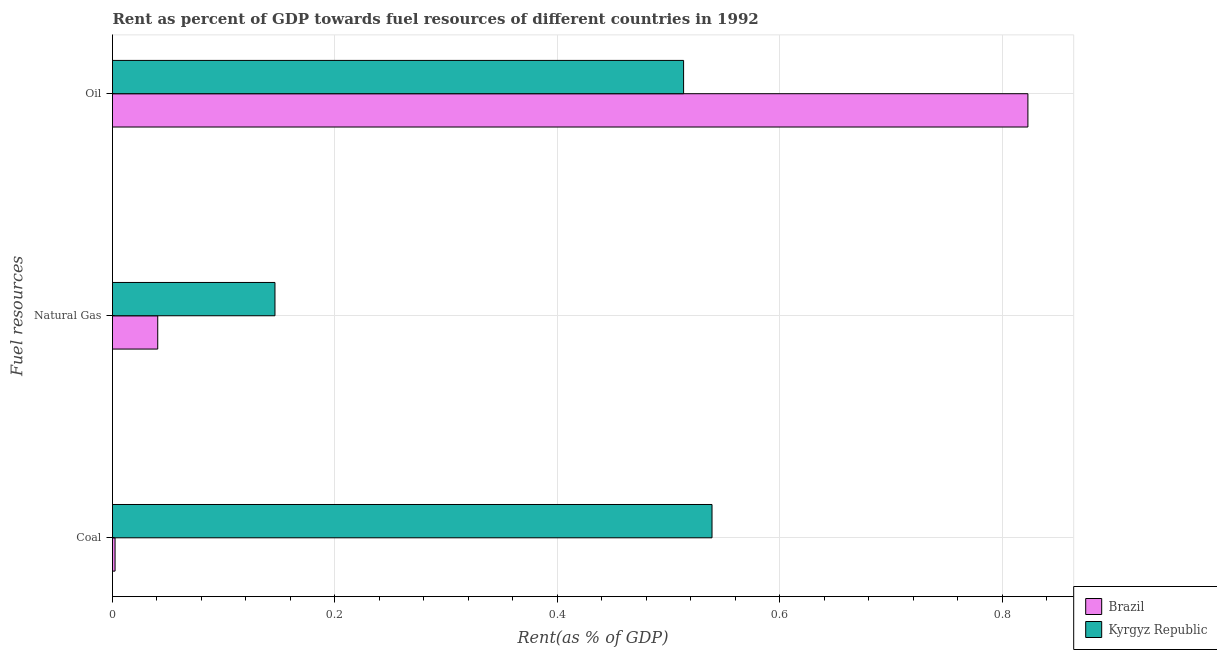How many different coloured bars are there?
Your response must be concise. 2. Are the number of bars per tick equal to the number of legend labels?
Your response must be concise. Yes. What is the label of the 3rd group of bars from the top?
Provide a short and direct response. Coal. What is the rent towards oil in Kyrgyz Republic?
Keep it short and to the point. 0.51. Across all countries, what is the maximum rent towards natural gas?
Offer a very short reply. 0.15. Across all countries, what is the minimum rent towards coal?
Provide a succinct answer. 0. In which country was the rent towards natural gas maximum?
Keep it short and to the point. Kyrgyz Republic. What is the total rent towards coal in the graph?
Give a very brief answer. 0.54. What is the difference between the rent towards natural gas in Brazil and that in Kyrgyz Republic?
Your response must be concise. -0.11. What is the difference between the rent towards natural gas in Brazil and the rent towards coal in Kyrgyz Republic?
Ensure brevity in your answer.  -0.5. What is the average rent towards oil per country?
Offer a terse response. 0.67. What is the difference between the rent towards coal and rent towards natural gas in Kyrgyz Republic?
Keep it short and to the point. 0.39. In how many countries, is the rent towards oil greater than 0.52 %?
Give a very brief answer. 1. What is the ratio of the rent towards oil in Brazil to that in Kyrgyz Republic?
Your response must be concise. 1.6. Is the rent towards oil in Kyrgyz Republic less than that in Brazil?
Provide a succinct answer. Yes. Is the difference between the rent towards natural gas in Kyrgyz Republic and Brazil greater than the difference between the rent towards coal in Kyrgyz Republic and Brazil?
Ensure brevity in your answer.  No. What is the difference between the highest and the second highest rent towards natural gas?
Your answer should be compact. 0.11. What is the difference between the highest and the lowest rent towards natural gas?
Offer a very short reply. 0.11. In how many countries, is the rent towards coal greater than the average rent towards coal taken over all countries?
Keep it short and to the point. 1. What does the 2nd bar from the top in Natural Gas represents?
Make the answer very short. Brazil. Is it the case that in every country, the sum of the rent towards coal and rent towards natural gas is greater than the rent towards oil?
Give a very brief answer. No. How many bars are there?
Provide a short and direct response. 6. Are the values on the major ticks of X-axis written in scientific E-notation?
Give a very brief answer. No. Does the graph contain grids?
Your answer should be compact. Yes. Where does the legend appear in the graph?
Offer a very short reply. Bottom right. How are the legend labels stacked?
Your answer should be compact. Vertical. What is the title of the graph?
Offer a terse response. Rent as percent of GDP towards fuel resources of different countries in 1992. Does "Libya" appear as one of the legend labels in the graph?
Keep it short and to the point. No. What is the label or title of the X-axis?
Keep it short and to the point. Rent(as % of GDP). What is the label or title of the Y-axis?
Provide a short and direct response. Fuel resources. What is the Rent(as % of GDP) in Brazil in Coal?
Ensure brevity in your answer.  0. What is the Rent(as % of GDP) in Kyrgyz Republic in Coal?
Your answer should be compact. 0.54. What is the Rent(as % of GDP) of Brazil in Natural Gas?
Provide a short and direct response. 0.04. What is the Rent(as % of GDP) in Kyrgyz Republic in Natural Gas?
Provide a short and direct response. 0.15. What is the Rent(as % of GDP) of Brazil in Oil?
Provide a short and direct response. 0.82. What is the Rent(as % of GDP) in Kyrgyz Republic in Oil?
Ensure brevity in your answer.  0.51. Across all Fuel resources, what is the maximum Rent(as % of GDP) of Brazil?
Your answer should be very brief. 0.82. Across all Fuel resources, what is the maximum Rent(as % of GDP) in Kyrgyz Republic?
Provide a short and direct response. 0.54. Across all Fuel resources, what is the minimum Rent(as % of GDP) of Brazil?
Your answer should be compact. 0. Across all Fuel resources, what is the minimum Rent(as % of GDP) in Kyrgyz Republic?
Give a very brief answer. 0.15. What is the total Rent(as % of GDP) of Brazil in the graph?
Give a very brief answer. 0.87. What is the total Rent(as % of GDP) of Kyrgyz Republic in the graph?
Offer a very short reply. 1.2. What is the difference between the Rent(as % of GDP) of Brazil in Coal and that in Natural Gas?
Offer a very short reply. -0.04. What is the difference between the Rent(as % of GDP) in Kyrgyz Republic in Coal and that in Natural Gas?
Provide a succinct answer. 0.39. What is the difference between the Rent(as % of GDP) of Brazil in Coal and that in Oil?
Offer a very short reply. -0.82. What is the difference between the Rent(as % of GDP) in Kyrgyz Republic in Coal and that in Oil?
Ensure brevity in your answer.  0.03. What is the difference between the Rent(as % of GDP) of Brazil in Natural Gas and that in Oil?
Ensure brevity in your answer.  -0.78. What is the difference between the Rent(as % of GDP) in Kyrgyz Republic in Natural Gas and that in Oil?
Your answer should be very brief. -0.37. What is the difference between the Rent(as % of GDP) of Brazil in Coal and the Rent(as % of GDP) of Kyrgyz Republic in Natural Gas?
Give a very brief answer. -0.14. What is the difference between the Rent(as % of GDP) of Brazil in Coal and the Rent(as % of GDP) of Kyrgyz Republic in Oil?
Provide a succinct answer. -0.51. What is the difference between the Rent(as % of GDP) of Brazil in Natural Gas and the Rent(as % of GDP) of Kyrgyz Republic in Oil?
Keep it short and to the point. -0.47. What is the average Rent(as % of GDP) of Brazil per Fuel resources?
Provide a succinct answer. 0.29. What is the average Rent(as % of GDP) in Kyrgyz Republic per Fuel resources?
Offer a terse response. 0.4. What is the difference between the Rent(as % of GDP) in Brazil and Rent(as % of GDP) in Kyrgyz Republic in Coal?
Make the answer very short. -0.54. What is the difference between the Rent(as % of GDP) in Brazil and Rent(as % of GDP) in Kyrgyz Republic in Natural Gas?
Your response must be concise. -0.11. What is the difference between the Rent(as % of GDP) in Brazil and Rent(as % of GDP) in Kyrgyz Republic in Oil?
Keep it short and to the point. 0.31. What is the ratio of the Rent(as % of GDP) in Brazil in Coal to that in Natural Gas?
Your answer should be very brief. 0.06. What is the ratio of the Rent(as % of GDP) of Kyrgyz Republic in Coal to that in Natural Gas?
Provide a short and direct response. 3.69. What is the ratio of the Rent(as % of GDP) in Brazil in Coal to that in Oil?
Ensure brevity in your answer.  0. What is the ratio of the Rent(as % of GDP) in Kyrgyz Republic in Coal to that in Oil?
Give a very brief answer. 1.05. What is the ratio of the Rent(as % of GDP) of Brazil in Natural Gas to that in Oil?
Give a very brief answer. 0.05. What is the ratio of the Rent(as % of GDP) of Kyrgyz Republic in Natural Gas to that in Oil?
Your response must be concise. 0.28. What is the difference between the highest and the second highest Rent(as % of GDP) of Brazil?
Offer a very short reply. 0.78. What is the difference between the highest and the second highest Rent(as % of GDP) in Kyrgyz Republic?
Offer a very short reply. 0.03. What is the difference between the highest and the lowest Rent(as % of GDP) of Brazil?
Give a very brief answer. 0.82. What is the difference between the highest and the lowest Rent(as % of GDP) in Kyrgyz Republic?
Offer a terse response. 0.39. 